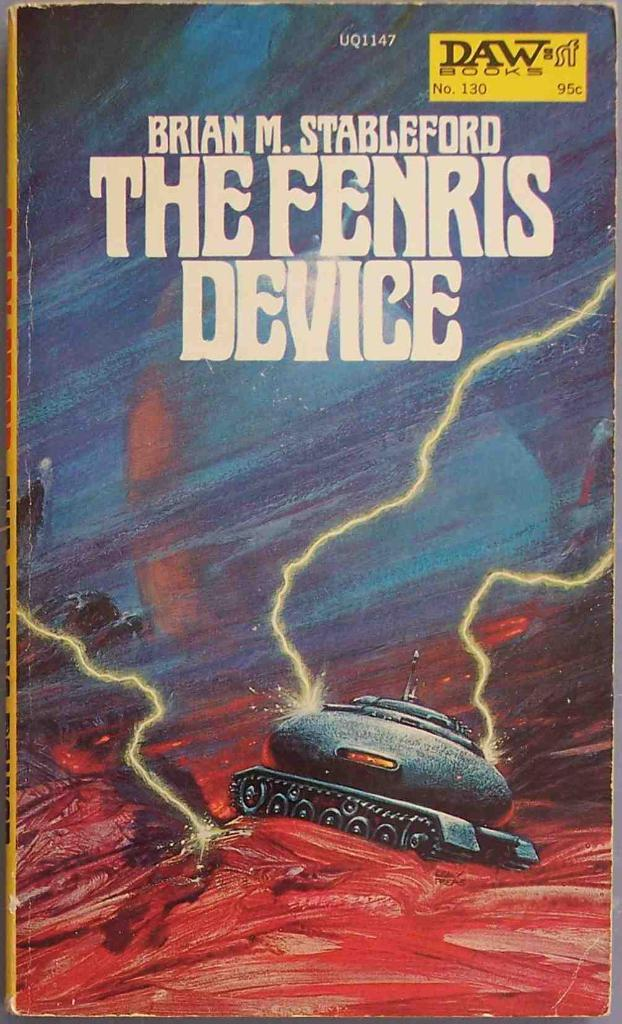<image>
Share a concise interpretation of the image provided. An old novel with a tank on it called The Fenris Device. 